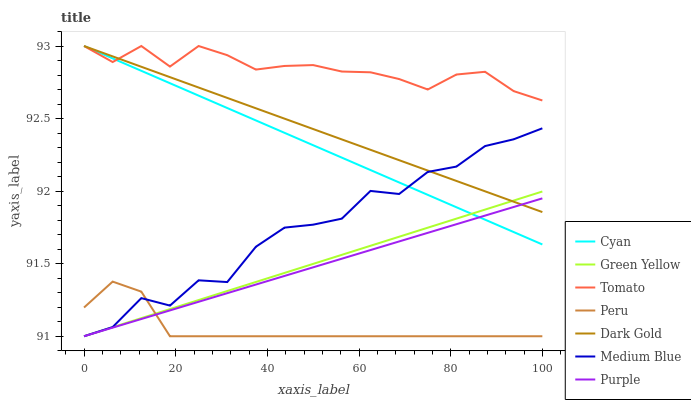Does Peru have the minimum area under the curve?
Answer yes or no. Yes. Does Tomato have the maximum area under the curve?
Answer yes or no. Yes. Does Dark Gold have the minimum area under the curve?
Answer yes or no. No. Does Dark Gold have the maximum area under the curve?
Answer yes or no. No. Is Purple the smoothest?
Answer yes or no. Yes. Is Medium Blue the roughest?
Answer yes or no. Yes. Is Dark Gold the smoothest?
Answer yes or no. No. Is Dark Gold the roughest?
Answer yes or no. No. Does Purple have the lowest value?
Answer yes or no. Yes. Does Dark Gold have the lowest value?
Answer yes or no. No. Does Cyan have the highest value?
Answer yes or no. Yes. Does Purple have the highest value?
Answer yes or no. No. Is Peru less than Dark Gold?
Answer yes or no. Yes. Is Tomato greater than Peru?
Answer yes or no. Yes. Does Tomato intersect Dark Gold?
Answer yes or no. Yes. Is Tomato less than Dark Gold?
Answer yes or no. No. Is Tomato greater than Dark Gold?
Answer yes or no. No. Does Peru intersect Dark Gold?
Answer yes or no. No. 